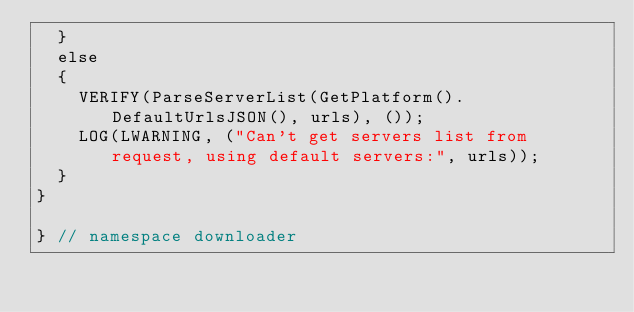<code> <loc_0><loc_0><loc_500><loc_500><_C++_>  }
  else
  {
    VERIFY(ParseServerList(GetPlatform().DefaultUrlsJSON(), urls), ());
    LOG(LWARNING, ("Can't get servers list from request, using default servers:", urls));
  }
}

} // namespace downloader
</code> 